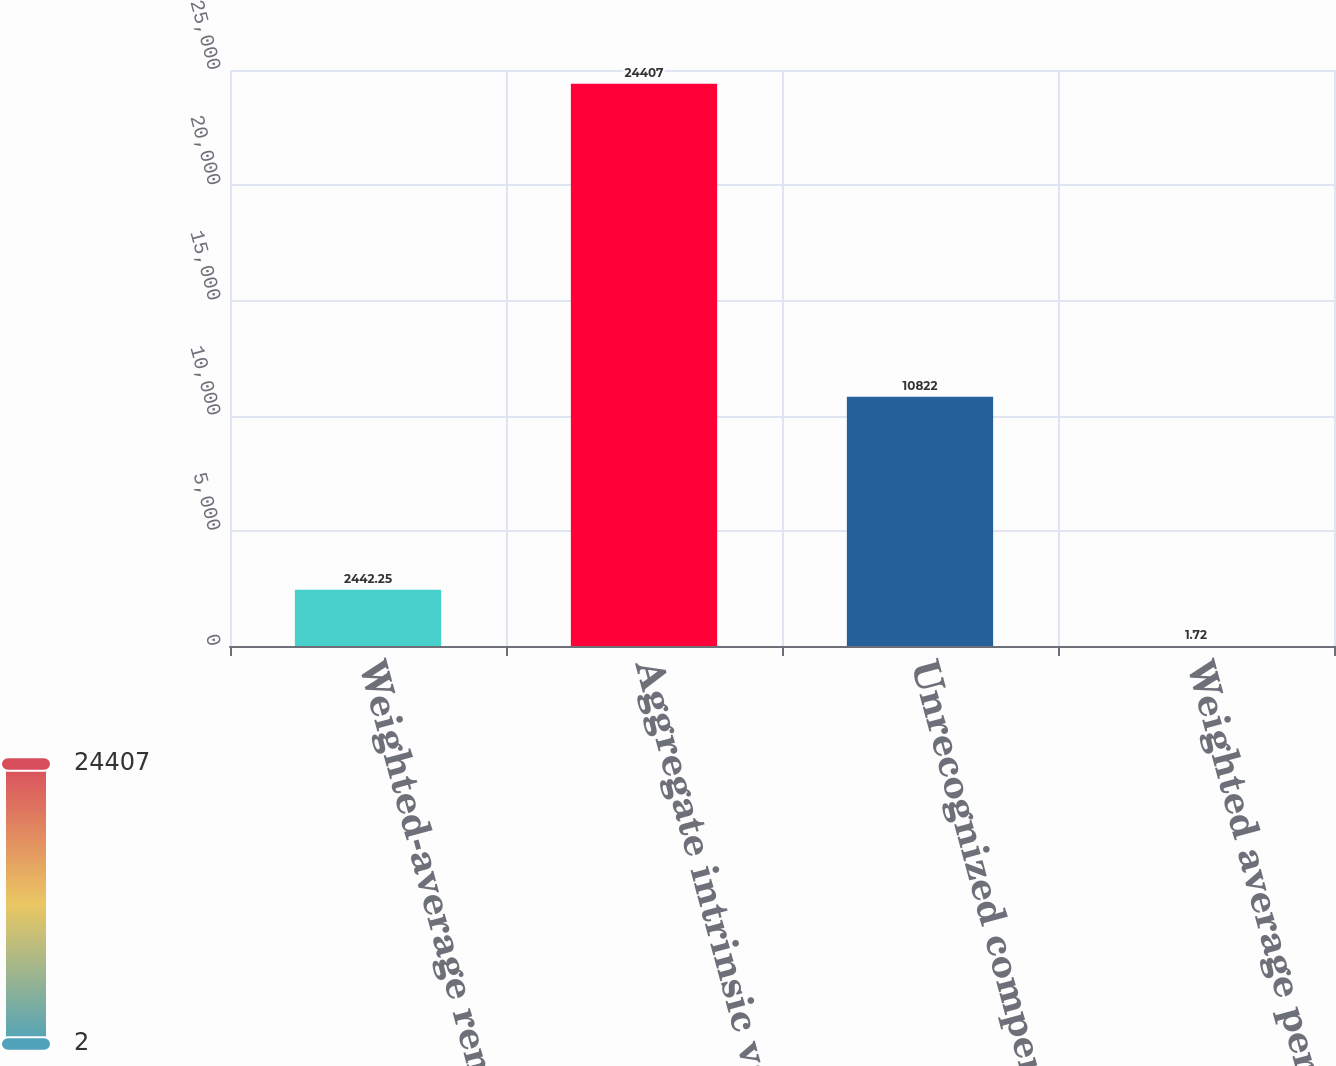Convert chart to OTSL. <chart><loc_0><loc_0><loc_500><loc_500><bar_chart><fcel>Weighted-average remaining<fcel>Aggregate intrinsic value<fcel>Unrecognized compensation<fcel>Weighted average period of<nl><fcel>2442.25<fcel>24407<fcel>10822<fcel>1.72<nl></chart> 